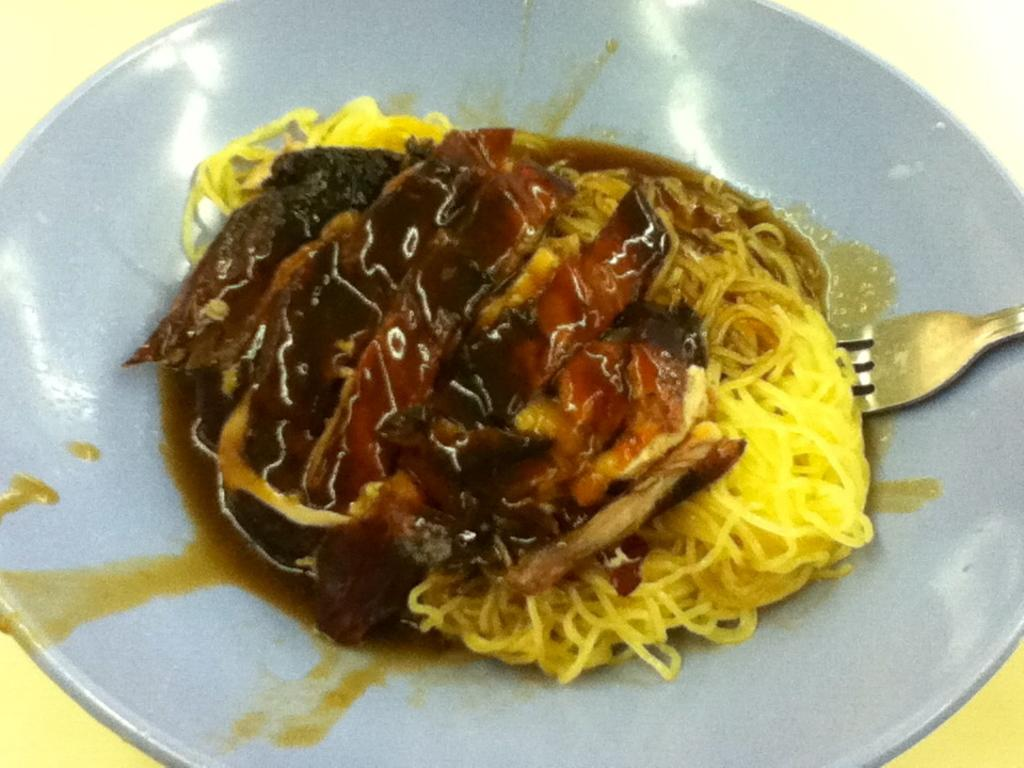What is present on the plate in the image? The plate has a fork on it, and there are food items on the plate. What type of utensil is on the plate? There is a fork on the plate. What color is the surface on which the plate is placed? The plate is placed on a yellow surface. Where is the mailbox located in the image? There is no mailbox present in the image. What type of neck accessory is visible on the plate? There is no neck accessory present in the image. 